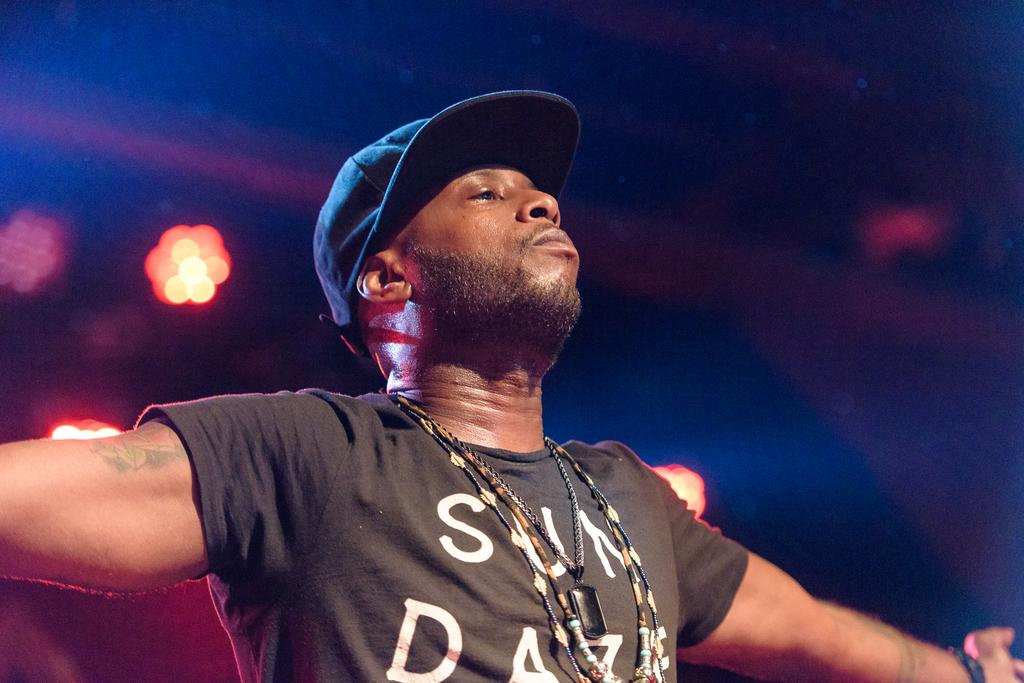What is the main subject of the image? There is a man standing in the image. Can you describe the man's attire? The man is wearing a cap. What can be observed about the background of the image? The background of the image is blurred. What else is visible in the background of the image? Lights are visible in the background of the image. What type of development is taking place in the image? There is no development project visible in the image; it features a man standing with a blurred background and visible lights. Can you describe the lift that is present in the image? There is no lift present in the image; it only shows a man standing with a cap, a blurred background, and visible lights. 